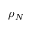<formula> <loc_0><loc_0><loc_500><loc_500>\rho _ { N }</formula> 